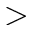Convert formula to latex. <formula><loc_0><loc_0><loc_500><loc_500>></formula> 